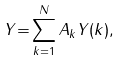<formula> <loc_0><loc_0><loc_500><loc_500>Y { = } \sum _ { k = 1 } ^ { N } A _ { k } Y ( k ) ,</formula> 